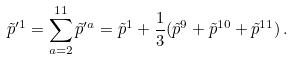Convert formula to latex. <formula><loc_0><loc_0><loc_500><loc_500>\tilde { p } ^ { \prime 1 } = \sum _ { a = 2 } ^ { 1 1 } \tilde { p } ^ { \prime a } = \tilde { p } ^ { 1 } + \frac { 1 } { 3 } ( \tilde { p } ^ { 9 } + \tilde { p } ^ { 1 0 } + \tilde { p } ^ { 1 1 } ) \, .</formula> 